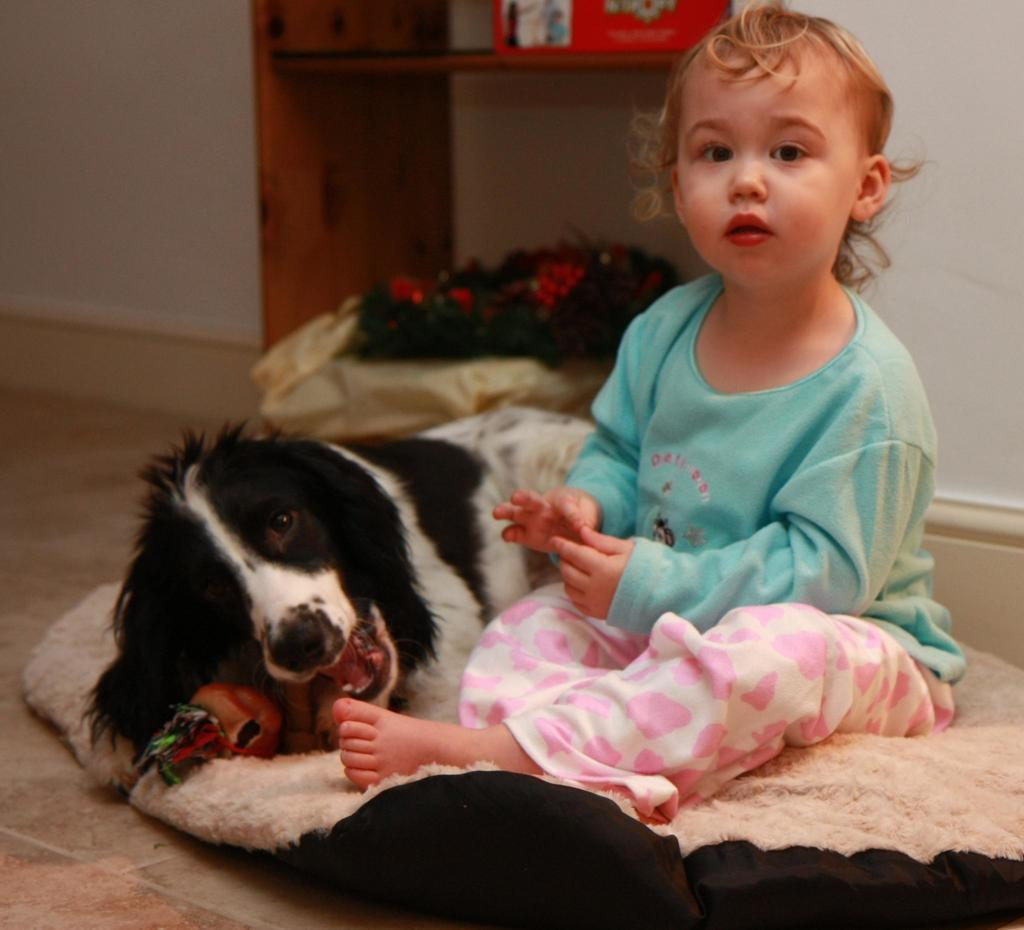What is located in the foreground of the image? There is a girl and a dog on a dog bed in the foreground of the image. What can be seen on the dog bed? A dog is on the dog bed in the foreground of the image. What is visible in the background of the image? There is a desk, a cardboard box, a wall, and a bouquet in the background of the image. What type of pin is holding the representative's tie in the image? There is no representative or tie present in the image, so it is not possible to determine what type of pin might be holding a tie. 